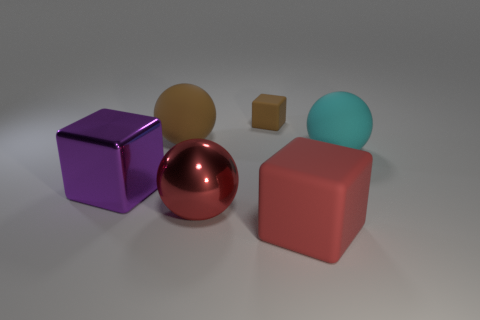There is a big shiny thing that is the same shape as the red matte object; what is its color?
Give a very brief answer. Purple. How many small brown rubber things have the same shape as the red matte thing?
Make the answer very short. 1. There is a thing that is the same color as the metal sphere; what material is it?
Provide a succinct answer. Rubber. What number of tiny gray matte balls are there?
Offer a terse response. 0. Are there any big red things made of the same material as the purple cube?
Your response must be concise. Yes. Does the matte ball that is to the left of the red cube have the same size as the matte block that is behind the large purple block?
Make the answer very short. No. What is the size of the matte cube that is behind the large red cube?
Ensure brevity in your answer.  Small. Is there a matte cube that has the same color as the metallic sphere?
Your response must be concise. Yes. There is a metal thing in front of the purple shiny object; are there any cyan spheres behind it?
Make the answer very short. Yes. Is the size of the red shiny ball the same as the matte cube behind the cyan matte sphere?
Offer a terse response. No. 